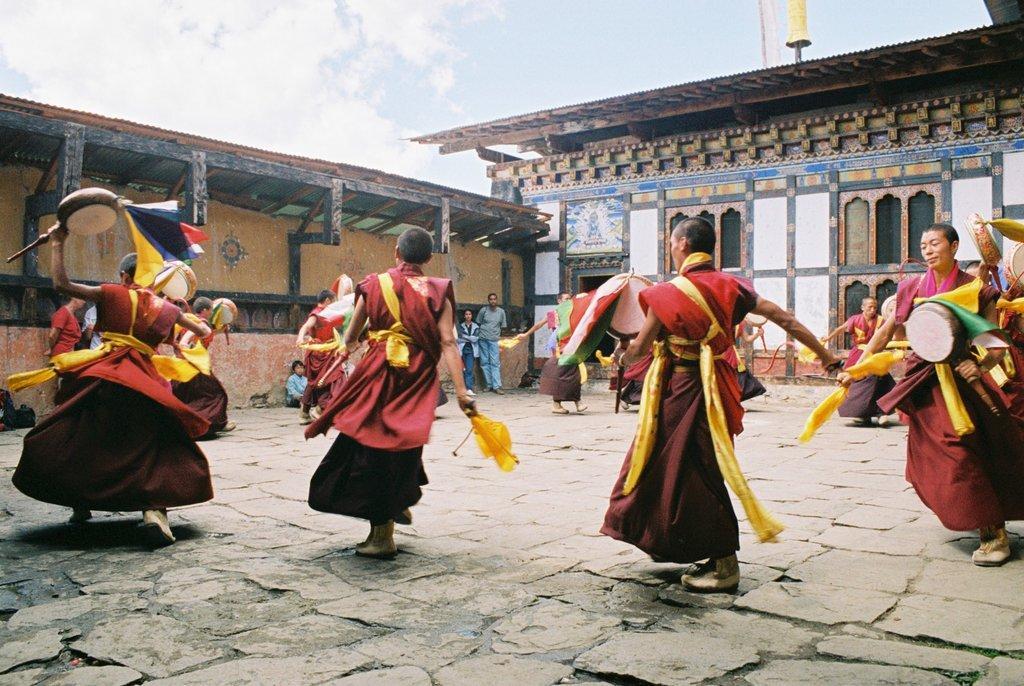In one or two sentences, can you explain what this image depicts? In this image we can see many persons on the ground. In the background we can see buildings, sky and clouds. 